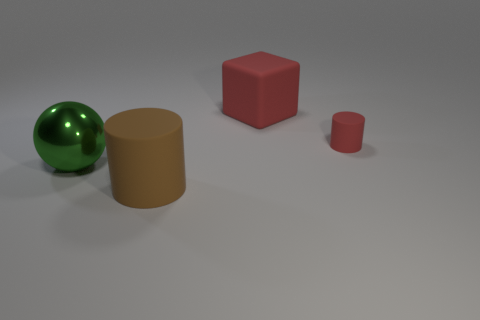Add 2 big rubber things. How many objects exist? 6 Subtract all cubes. How many objects are left? 3 Add 2 small cylinders. How many small cylinders are left? 3 Add 2 brown cylinders. How many brown cylinders exist? 3 Subtract 0 yellow spheres. How many objects are left? 4 Subtract all small matte cylinders. Subtract all large red matte blocks. How many objects are left? 2 